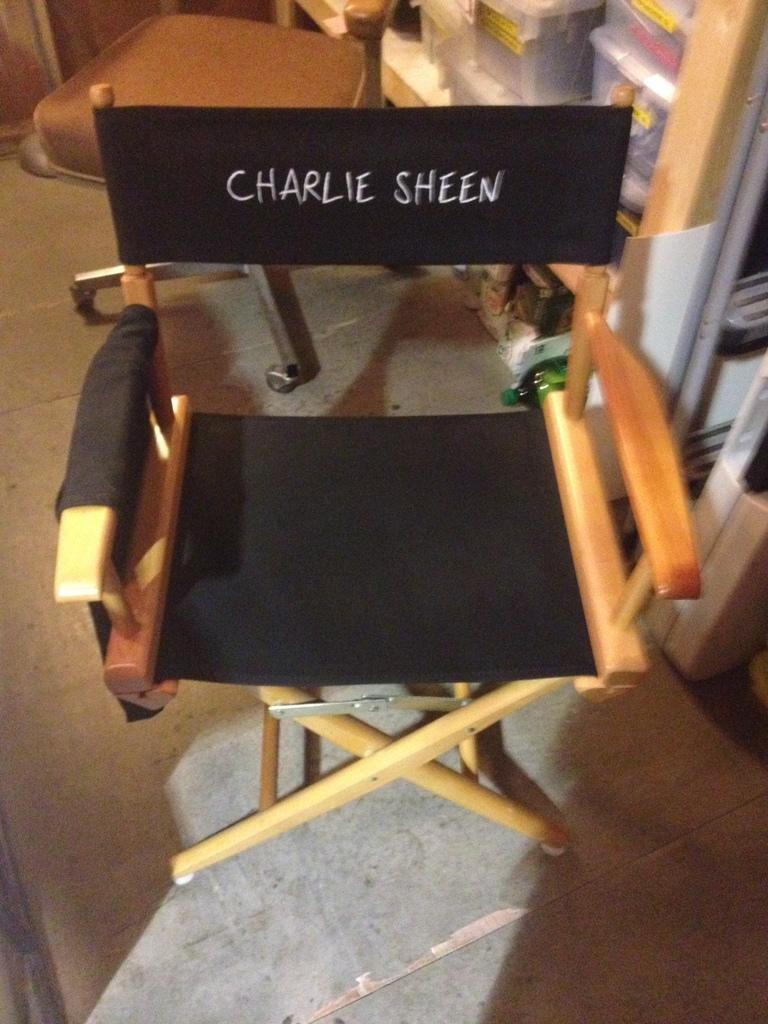How would you summarize this image in a sentence or two? In this image, this looks like a chair with a name on it. I think this is the stool with the wheels. These are the boxes, which are placed in the rack. This is the floor. 